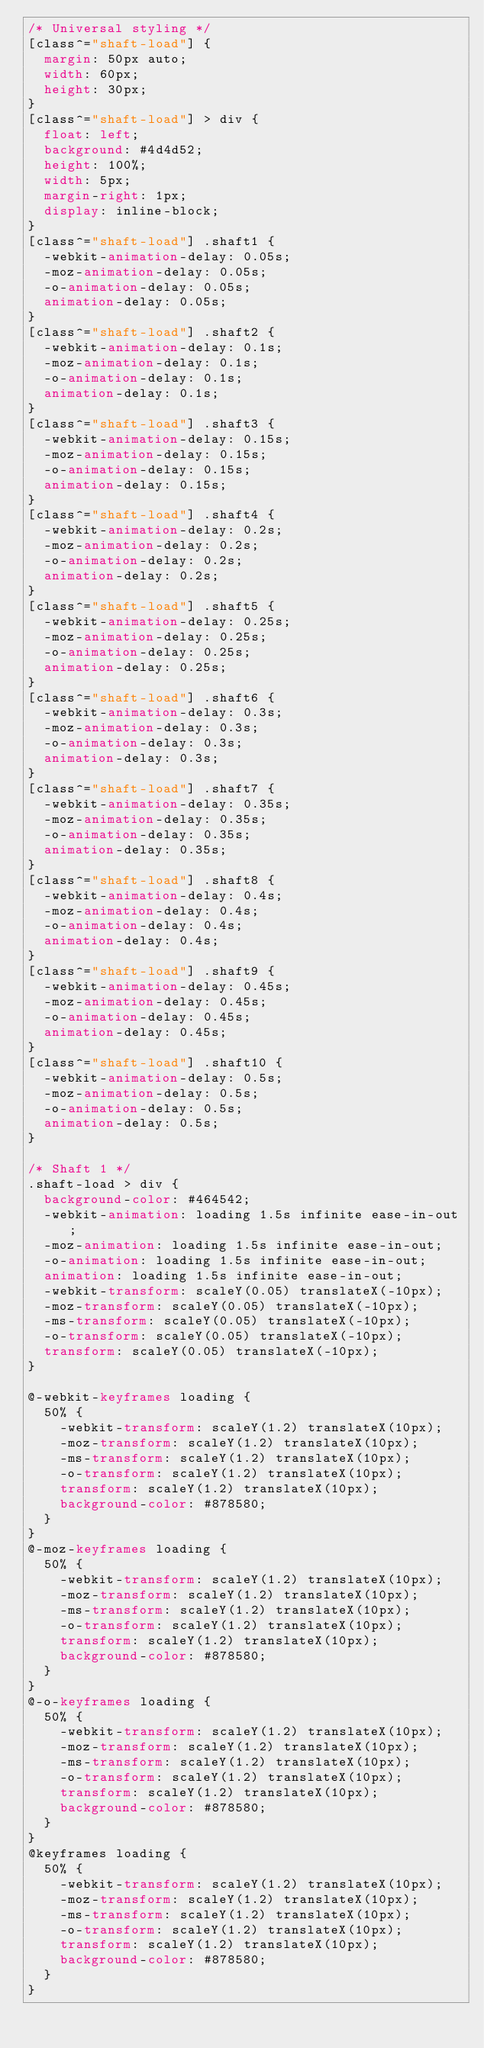<code> <loc_0><loc_0><loc_500><loc_500><_CSS_>/* Universal styling */
[class^="shaft-load"] {
  margin: 50px auto;
  width: 60px;
  height: 30px;
}
[class^="shaft-load"] > div {
  float: left;
  background: #4d4d52;
  height: 100%;
  width: 5px;
  margin-right: 1px;
  display: inline-block;
}
[class^="shaft-load"] .shaft1 {
  -webkit-animation-delay: 0.05s;
  -moz-animation-delay: 0.05s;
  -o-animation-delay: 0.05s;
  animation-delay: 0.05s;
}
[class^="shaft-load"] .shaft2 {
  -webkit-animation-delay: 0.1s;
  -moz-animation-delay: 0.1s;
  -o-animation-delay: 0.1s;
  animation-delay: 0.1s;
}
[class^="shaft-load"] .shaft3 {
  -webkit-animation-delay: 0.15s;
  -moz-animation-delay: 0.15s;
  -o-animation-delay: 0.15s;
  animation-delay: 0.15s;
}
[class^="shaft-load"] .shaft4 {
  -webkit-animation-delay: 0.2s;
  -moz-animation-delay: 0.2s;
  -o-animation-delay: 0.2s;
  animation-delay: 0.2s;
}
[class^="shaft-load"] .shaft5 {
  -webkit-animation-delay: 0.25s;
  -moz-animation-delay: 0.25s;
  -o-animation-delay: 0.25s;
  animation-delay: 0.25s;
}
[class^="shaft-load"] .shaft6 {
  -webkit-animation-delay: 0.3s;
  -moz-animation-delay: 0.3s;
  -o-animation-delay: 0.3s;
  animation-delay: 0.3s;
}
[class^="shaft-load"] .shaft7 {
  -webkit-animation-delay: 0.35s;
  -moz-animation-delay: 0.35s;
  -o-animation-delay: 0.35s;
  animation-delay: 0.35s;
}
[class^="shaft-load"] .shaft8 {
  -webkit-animation-delay: 0.4s;
  -moz-animation-delay: 0.4s;
  -o-animation-delay: 0.4s;
  animation-delay: 0.4s;
}
[class^="shaft-load"] .shaft9 {
  -webkit-animation-delay: 0.45s;
  -moz-animation-delay: 0.45s;
  -o-animation-delay: 0.45s;
  animation-delay: 0.45s;
}
[class^="shaft-load"] .shaft10 {
  -webkit-animation-delay: 0.5s;
  -moz-animation-delay: 0.5s;
  -o-animation-delay: 0.5s;
  animation-delay: 0.5s;
}

/* Shaft 1 */
.shaft-load > div {
  background-color: #464542;
  -webkit-animation: loading 1.5s infinite ease-in-out;
  -moz-animation: loading 1.5s infinite ease-in-out;
  -o-animation: loading 1.5s infinite ease-in-out;
  animation: loading 1.5s infinite ease-in-out;
  -webkit-transform: scaleY(0.05) translateX(-10px);
  -moz-transform: scaleY(0.05) translateX(-10px);
  -ms-transform: scaleY(0.05) translateX(-10px);
  -o-transform: scaleY(0.05) translateX(-10px);
  transform: scaleY(0.05) translateX(-10px);
}

@-webkit-keyframes loading {
  50% {
    -webkit-transform: scaleY(1.2) translateX(10px);
    -moz-transform: scaleY(1.2) translateX(10px);
    -ms-transform: scaleY(1.2) translateX(10px);
    -o-transform: scaleY(1.2) translateX(10px);
    transform: scaleY(1.2) translateX(10px);
    background-color: #878580;
  }
}
@-moz-keyframes loading {
  50% {
    -webkit-transform: scaleY(1.2) translateX(10px);
    -moz-transform: scaleY(1.2) translateX(10px);
    -ms-transform: scaleY(1.2) translateX(10px);
    -o-transform: scaleY(1.2) translateX(10px);
    transform: scaleY(1.2) translateX(10px);
    background-color: #878580;
  }
}
@-o-keyframes loading {
  50% {
    -webkit-transform: scaleY(1.2) translateX(10px);
    -moz-transform: scaleY(1.2) translateX(10px);
    -ms-transform: scaleY(1.2) translateX(10px);
    -o-transform: scaleY(1.2) translateX(10px);
    transform: scaleY(1.2) translateX(10px);
    background-color: #878580;
  }
}
@keyframes loading {
  50% {
    -webkit-transform: scaleY(1.2) translateX(10px);
    -moz-transform: scaleY(1.2) translateX(10px);
    -ms-transform: scaleY(1.2) translateX(10px);
    -o-transform: scaleY(1.2) translateX(10px);
    transform: scaleY(1.2) translateX(10px);
    background-color: #878580;
  }
}</code> 